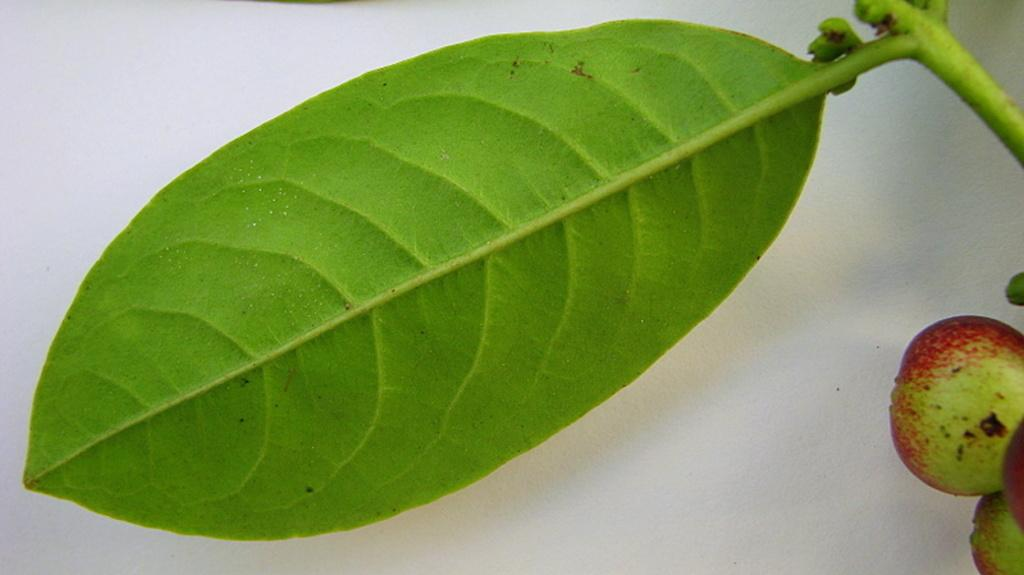What is located in the foreground of the image? There is a leaf in the foreground of the image. What can be seen on the right side of the image? There are fruits on the right side of the image. Can you describe the background of the image? The background of the image is blurred. Where is the crate located in the image? There is no crate present in the image. What type of hen can be seen interacting with the leaf in the image? There is no hen present in the image; it only features a leaf and fruits. 